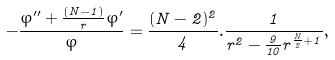<formula> <loc_0><loc_0><loc_500><loc_500>- \frac { \varphi ^ { \prime \prime } + \frac { ( N - 1 ) } { r } \varphi ^ { \prime } } { \varphi } = \frac { ( N - 2 ) ^ { 2 } } { 4 } . \frac { 1 } { r ^ { 2 } - \frac { 9 } { 1 0 } r ^ { \frac { N } { 2 } + 1 } } ,</formula> 